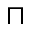<formula> <loc_0><loc_0><loc_500><loc_500>\sqcap</formula> 